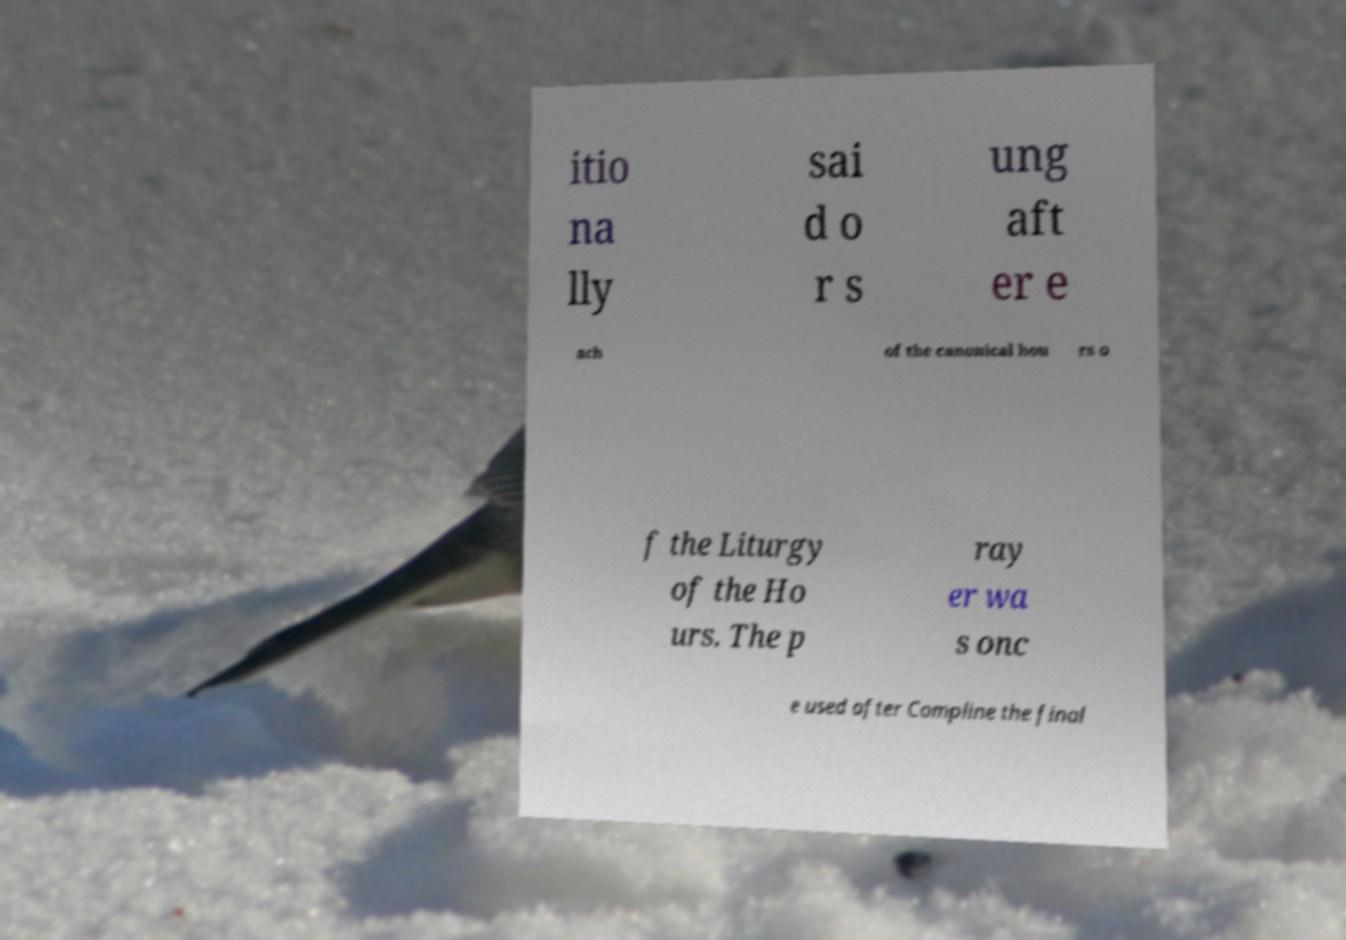Please identify and transcribe the text found in this image. itio na lly sai d o r s ung aft er e ach of the canonical hou rs o f the Liturgy of the Ho urs. The p ray er wa s onc e used after Compline the final 